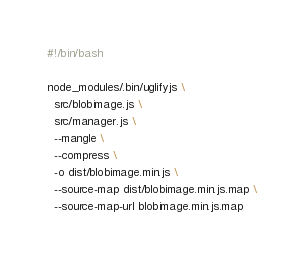Convert code to text. <code><loc_0><loc_0><loc_500><loc_500><_Bash_>#!/bin/bash

node_modules/.bin/uglifyjs \
  src/blobimage.js \
  src/manager.js \
  --mangle \
  --compress \
  -o dist/blobimage.min.js \
  --source-map dist/blobimage.min.js.map \
  --source-map-url blobimage.min.js.map </code> 